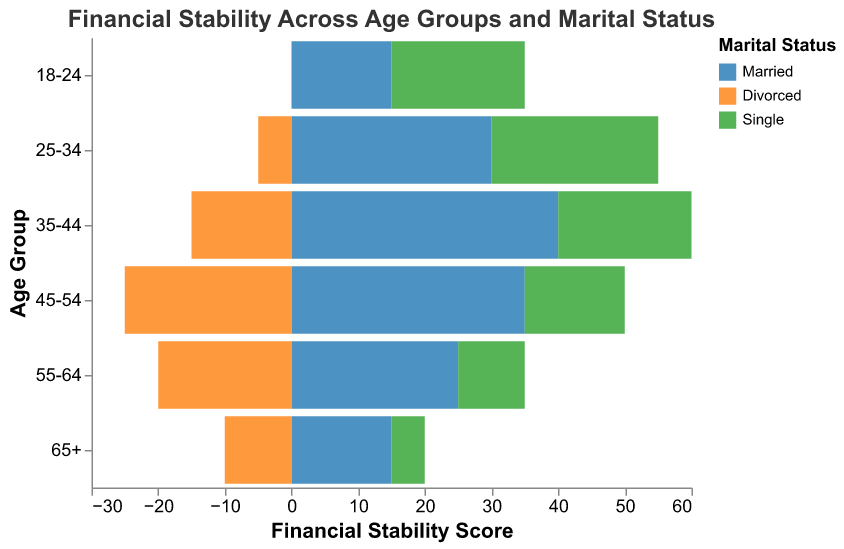What is the title of the figure? The title is generally located at the top of the figure and is directly readable.
Answer: Financial Stability Across Age Groups and Marital Status What are the age groups listed on the y-axis? The y-axis labels correspond to the age groups defined in the figure's data.
Answer: 18-24, 25-34, 35-44, 45-54, 55-64, 65+ What color represents the "Single" marital status in the figure? Each marital status is represented by a different color, which is shown in the legend.
Answer: Green In which age group do "Divorced" individuals show the lowest financial stability score? The bars representing "Divorced" individuals are shown in the figure, and the lowest point can be identified by comparing their positions.
Answer: Age group 45-54 What is the financial stability score for "Married" individuals in the 35-44 age group? The score is given as a negative value on the x-axis for "Married" individuals in the 35-44 age group.
Answer: -40 How does the financial stability of "Divorced" individuals aged 25-34 compare to those aged 55-64? Identify the values for both age groups for "Divorced" individuals and compare them.
Answer: Lower for age 25-34 (score of -5) compared to age 55-64 (score of -20) What is the average financial stability score for "Single" individuals across all age groups? Calculate the sum of the scores for "Single" individuals across all age groups and divide by the number of age groups (6).
Answer: (20 + 25 + 20 + 15 + 10 + 5) / 6 = 15.83 Which marital status shows a consistent trend of increasing financial stability with age? Compare the financial stability scores for each marital status across age groups to identify any trends.
Answer: Single What is the difference in financial stability scores between "Married" and "Single" individuals in the 45-54 age group? Subtract the financial stability score of "Married" individuals from that of "Single" individuals in the 45-54 age group.
Answer: 15 - (-35) = 50 Among the "Married" and "Divorced" groups, which shows the largest shift in financial stability score between any two consecutive age groups? Calculate the differences between consecutive age group scores for both "Married" and "Divorced" groups, and find the largest.
Answer: "Married" group from 18-24 to 25-34 (-30 - (-15) = -15) 